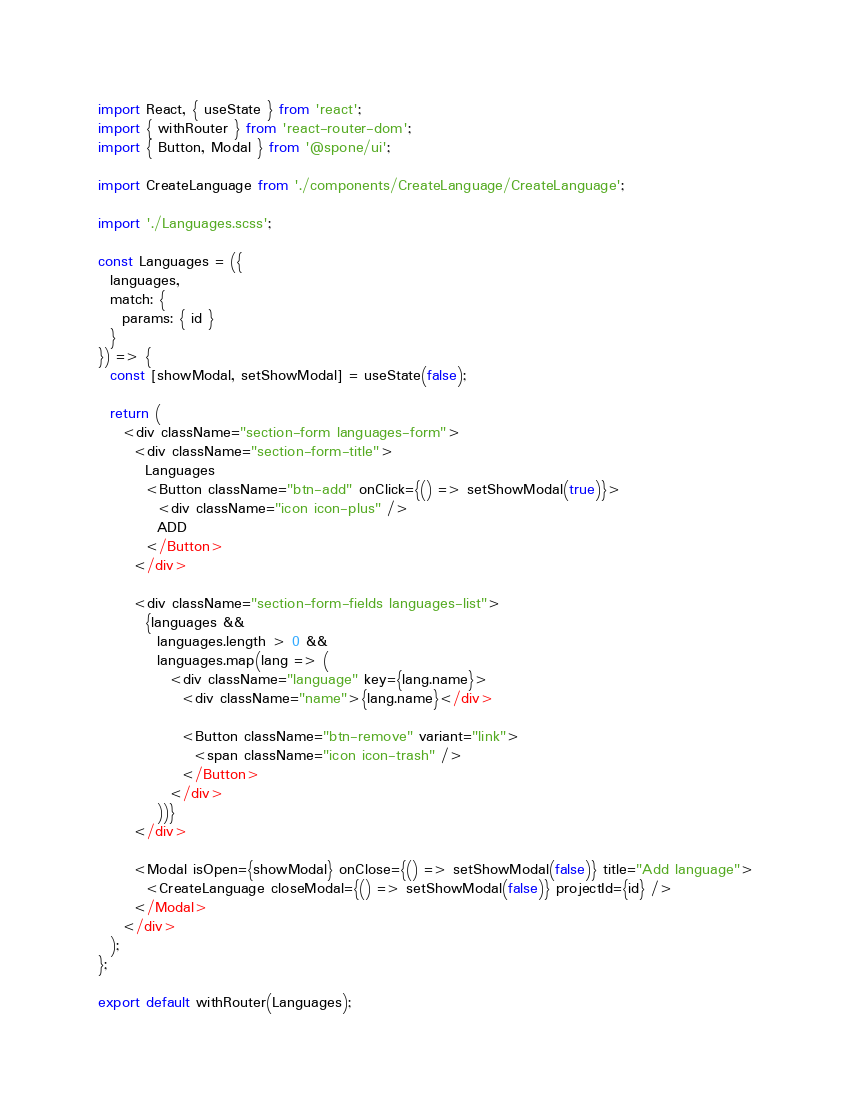<code> <loc_0><loc_0><loc_500><loc_500><_JavaScript_>import React, { useState } from 'react';
import { withRouter } from 'react-router-dom';
import { Button, Modal } from '@spone/ui';

import CreateLanguage from './components/CreateLanguage/CreateLanguage';

import './Languages.scss';

const Languages = ({
  languages,
  match: {
    params: { id }
  }
}) => {
  const [showModal, setShowModal] = useState(false);

  return (
    <div className="section-form languages-form">
      <div className="section-form-title">
        Languages
        <Button className="btn-add" onClick={() => setShowModal(true)}>
          <div className="icon icon-plus" />
          ADD
        </Button>
      </div>

      <div className="section-form-fields languages-list">
        {languages &&
          languages.length > 0 &&
          languages.map(lang => (
            <div className="language" key={lang.name}>
              <div className="name">{lang.name}</div>

              <Button className="btn-remove" variant="link">
                <span className="icon icon-trash" />
              </Button>
            </div>
          ))}
      </div>

      <Modal isOpen={showModal} onClose={() => setShowModal(false)} title="Add language">
        <CreateLanguage closeModal={() => setShowModal(false)} projectId={id} />
      </Modal>
    </div>
  );
};

export default withRouter(Languages);
</code> 